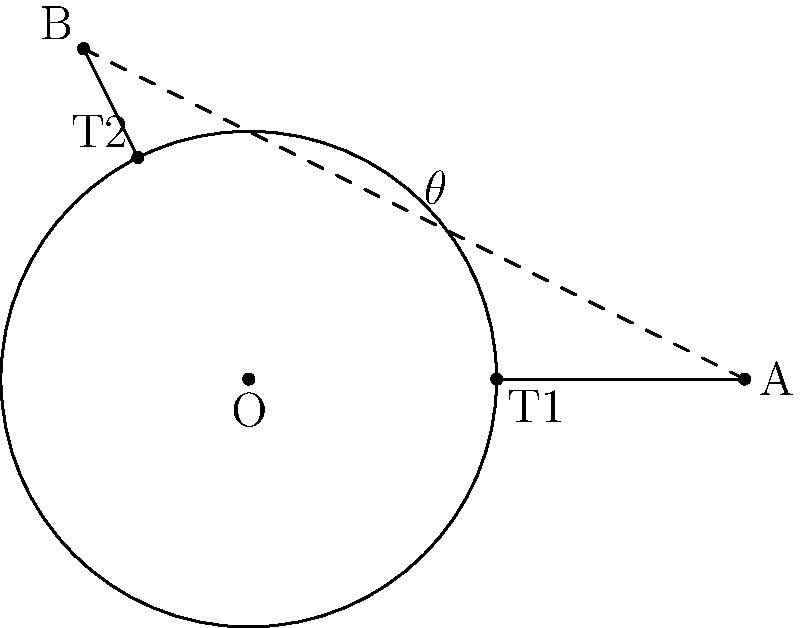In a financial model representing market volatility, two tangent lines are drawn from external points A and B to a circle centered at O with radius 1.5 units. If the line segment AB passes through point (1,1) and has a length of 5 units, what is the measure of angle $\theta$ formed between these tangent lines? To solve this problem, we'll follow these steps:

1) First, recall that the angle between two tangent lines drawn from an external point to a circle is equal to the angle subtended by the two points of tangency at the center of the circle.

2) In this case, angle $\theta$ is equal to the angle subtended by T1 and T2 at O.

3) We can find this angle using the properties of right triangles. In both right triangles OAT1 and OBT2, the tangent lines are perpendicular to the radii.

4) The key insight is that the angle between OA and OB is supplementary to $\theta$. In other words:

   $$\angle AOB + \theta = 180°$$

5) We can find $\angle AOB$ using the cosine formula:

   $$\cos(\angle AOB) = \frac{OA^2 + OB^2 - AB^2}{2 \cdot OA \cdot OB}$$

6) We know AB = 5, and we can find OA and OB using the Pythagorean theorem:

   $$OA = \sqrt{3^2 + 1^2} = \sqrt{10}$$
   $$OB = \sqrt{(-1-1)^2 + (2-1)^2} = \sqrt{5}$$

7) Substituting into the cosine formula:

   $$\cos(\angle AOB) = \frac{10 + 5 - 25}{2 \sqrt{10} \sqrt{5}} = -\frac{5}{2\sqrt{50}} = -\frac{1}{2\sqrt{2}}$$

8) Taking the inverse cosine:

   $$\angle AOB = \arccos(-\frac{1}{2\sqrt{2}}) \approx 135°$$

9) Therefore:

   $$\theta = 180° - 135° = 45°$$
Answer: 45° 